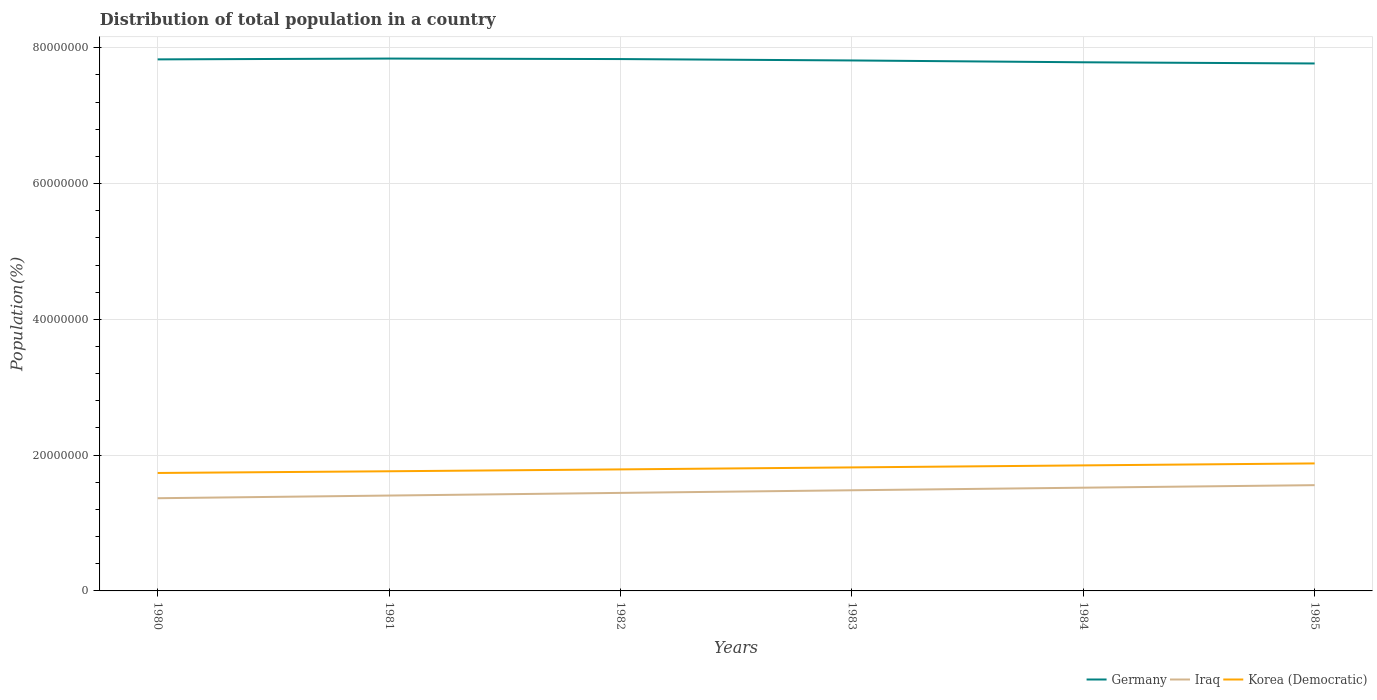How many different coloured lines are there?
Your answer should be compact. 3. Across all years, what is the maximum population of in Iraq?
Your answer should be very brief. 1.37e+07. In which year was the population of in Korea (Democratic) maximum?
Your response must be concise. 1980. What is the total population of in Germany in the graph?
Provide a succinct answer. 2.05e+05. What is the difference between the highest and the second highest population of in Iraq?
Offer a very short reply. 1.92e+06. What is the difference between two consecutive major ticks on the Y-axis?
Make the answer very short. 2.00e+07. Are the values on the major ticks of Y-axis written in scientific E-notation?
Give a very brief answer. No. Does the graph contain grids?
Make the answer very short. Yes. How are the legend labels stacked?
Make the answer very short. Horizontal. What is the title of the graph?
Keep it short and to the point. Distribution of total population in a country. What is the label or title of the X-axis?
Give a very brief answer. Years. What is the label or title of the Y-axis?
Your response must be concise. Population(%). What is the Population(%) of Germany in 1980?
Your answer should be very brief. 7.83e+07. What is the Population(%) in Iraq in 1980?
Give a very brief answer. 1.37e+07. What is the Population(%) of Korea (Democratic) in 1980?
Keep it short and to the point. 1.74e+07. What is the Population(%) in Germany in 1981?
Your answer should be very brief. 7.84e+07. What is the Population(%) in Iraq in 1981?
Your answer should be very brief. 1.40e+07. What is the Population(%) of Korea (Democratic) in 1981?
Offer a terse response. 1.76e+07. What is the Population(%) in Germany in 1982?
Your response must be concise. 7.83e+07. What is the Population(%) of Iraq in 1982?
Your response must be concise. 1.44e+07. What is the Population(%) in Korea (Democratic) in 1982?
Offer a terse response. 1.79e+07. What is the Population(%) in Germany in 1983?
Your response must be concise. 7.81e+07. What is the Population(%) of Iraq in 1983?
Your answer should be very brief. 1.48e+07. What is the Population(%) of Korea (Democratic) in 1983?
Offer a very short reply. 1.82e+07. What is the Population(%) of Germany in 1984?
Offer a very short reply. 7.79e+07. What is the Population(%) in Iraq in 1984?
Keep it short and to the point. 1.52e+07. What is the Population(%) in Korea (Democratic) in 1984?
Give a very brief answer. 1.85e+07. What is the Population(%) of Germany in 1985?
Keep it short and to the point. 7.77e+07. What is the Population(%) of Iraq in 1985?
Your answer should be compact. 1.56e+07. What is the Population(%) in Korea (Democratic) in 1985?
Offer a terse response. 1.88e+07. Across all years, what is the maximum Population(%) in Germany?
Ensure brevity in your answer.  7.84e+07. Across all years, what is the maximum Population(%) in Iraq?
Ensure brevity in your answer.  1.56e+07. Across all years, what is the maximum Population(%) in Korea (Democratic)?
Your answer should be compact. 1.88e+07. Across all years, what is the minimum Population(%) of Germany?
Provide a succinct answer. 7.77e+07. Across all years, what is the minimum Population(%) of Iraq?
Give a very brief answer. 1.37e+07. Across all years, what is the minimum Population(%) in Korea (Democratic)?
Make the answer very short. 1.74e+07. What is the total Population(%) in Germany in the graph?
Provide a succinct answer. 4.69e+08. What is the total Population(%) in Iraq in the graph?
Ensure brevity in your answer.  8.77e+07. What is the total Population(%) of Korea (Democratic) in the graph?
Ensure brevity in your answer.  1.08e+08. What is the difference between the Population(%) in Germany in 1980 and that in 1981?
Your answer should be compact. -1.19e+05. What is the difference between the Population(%) in Iraq in 1980 and that in 1981?
Your response must be concise. -3.93e+05. What is the difference between the Population(%) in Korea (Democratic) in 1980 and that in 1981?
Your response must be concise. -2.51e+05. What is the difference between the Population(%) of Germany in 1980 and that in 1982?
Your answer should be compact. -4.48e+04. What is the difference between the Population(%) in Iraq in 1980 and that in 1982?
Make the answer very short. -7.84e+05. What is the difference between the Population(%) in Korea (Democratic) in 1980 and that in 1982?
Provide a succinct answer. -5.27e+05. What is the difference between the Population(%) in Germany in 1980 and that in 1983?
Your response must be concise. 1.60e+05. What is the difference between the Population(%) of Iraq in 1980 and that in 1983?
Your answer should be compact. -1.17e+06. What is the difference between the Population(%) in Korea (Democratic) in 1980 and that in 1983?
Ensure brevity in your answer.  -8.20e+05. What is the difference between the Population(%) of Germany in 1980 and that in 1984?
Provide a succinct answer. 4.30e+05. What is the difference between the Population(%) of Iraq in 1980 and that in 1984?
Give a very brief answer. -1.55e+06. What is the difference between the Population(%) of Korea (Democratic) in 1980 and that in 1984?
Offer a terse response. -1.12e+06. What is the difference between the Population(%) in Germany in 1980 and that in 1985?
Your response must be concise. 6.04e+05. What is the difference between the Population(%) of Iraq in 1980 and that in 1985?
Offer a very short reply. -1.92e+06. What is the difference between the Population(%) of Korea (Democratic) in 1980 and that in 1985?
Keep it short and to the point. -1.41e+06. What is the difference between the Population(%) in Germany in 1981 and that in 1982?
Ensure brevity in your answer.  7.45e+04. What is the difference between the Population(%) of Iraq in 1981 and that in 1982?
Offer a terse response. -3.91e+05. What is the difference between the Population(%) of Korea (Democratic) in 1981 and that in 1982?
Offer a terse response. -2.76e+05. What is the difference between the Population(%) of Germany in 1981 and that in 1983?
Provide a short and direct response. 2.80e+05. What is the difference between the Population(%) in Iraq in 1981 and that in 1983?
Your response must be concise. -7.79e+05. What is the difference between the Population(%) of Korea (Democratic) in 1981 and that in 1983?
Make the answer very short. -5.69e+05. What is the difference between the Population(%) of Germany in 1981 and that in 1984?
Offer a very short reply. 5.49e+05. What is the difference between the Population(%) in Iraq in 1981 and that in 1984?
Offer a very short reply. -1.16e+06. What is the difference between the Population(%) in Korea (Democratic) in 1981 and that in 1984?
Provide a short and direct response. -8.65e+05. What is the difference between the Population(%) in Germany in 1981 and that in 1985?
Keep it short and to the point. 7.23e+05. What is the difference between the Population(%) in Iraq in 1981 and that in 1985?
Give a very brief answer. -1.53e+06. What is the difference between the Population(%) in Korea (Democratic) in 1981 and that in 1985?
Offer a very short reply. -1.15e+06. What is the difference between the Population(%) in Germany in 1982 and that in 1983?
Your response must be concise. 2.05e+05. What is the difference between the Population(%) of Iraq in 1982 and that in 1983?
Give a very brief answer. -3.87e+05. What is the difference between the Population(%) in Korea (Democratic) in 1982 and that in 1983?
Keep it short and to the point. -2.93e+05. What is the difference between the Population(%) of Germany in 1982 and that in 1984?
Keep it short and to the point. 4.75e+05. What is the difference between the Population(%) of Iraq in 1982 and that in 1984?
Your response must be concise. -7.67e+05. What is the difference between the Population(%) in Korea (Democratic) in 1982 and that in 1984?
Give a very brief answer. -5.89e+05. What is the difference between the Population(%) of Germany in 1982 and that in 1985?
Ensure brevity in your answer.  6.48e+05. What is the difference between the Population(%) of Iraq in 1982 and that in 1985?
Your response must be concise. -1.14e+06. What is the difference between the Population(%) of Korea (Democratic) in 1982 and that in 1985?
Provide a short and direct response. -8.79e+05. What is the difference between the Population(%) in Germany in 1983 and that in 1984?
Your answer should be compact. 2.70e+05. What is the difference between the Population(%) of Iraq in 1983 and that in 1984?
Ensure brevity in your answer.  -3.80e+05. What is the difference between the Population(%) in Korea (Democratic) in 1983 and that in 1984?
Your answer should be compact. -2.96e+05. What is the difference between the Population(%) in Germany in 1983 and that in 1985?
Keep it short and to the point. 4.43e+05. What is the difference between the Population(%) of Iraq in 1983 and that in 1985?
Offer a very short reply. -7.52e+05. What is the difference between the Population(%) in Korea (Democratic) in 1983 and that in 1985?
Give a very brief answer. -5.86e+05. What is the difference between the Population(%) in Germany in 1984 and that in 1985?
Offer a very short reply. 1.74e+05. What is the difference between the Population(%) in Iraq in 1984 and that in 1985?
Your answer should be compact. -3.72e+05. What is the difference between the Population(%) of Korea (Democratic) in 1984 and that in 1985?
Offer a very short reply. -2.90e+05. What is the difference between the Population(%) of Germany in 1980 and the Population(%) of Iraq in 1981?
Make the answer very short. 6.42e+07. What is the difference between the Population(%) in Germany in 1980 and the Population(%) in Korea (Democratic) in 1981?
Provide a succinct answer. 6.07e+07. What is the difference between the Population(%) of Iraq in 1980 and the Population(%) of Korea (Democratic) in 1981?
Provide a short and direct response. -3.97e+06. What is the difference between the Population(%) of Germany in 1980 and the Population(%) of Iraq in 1982?
Your answer should be very brief. 6.39e+07. What is the difference between the Population(%) of Germany in 1980 and the Population(%) of Korea (Democratic) in 1982?
Offer a very short reply. 6.04e+07. What is the difference between the Population(%) in Iraq in 1980 and the Population(%) in Korea (Democratic) in 1982?
Your answer should be compact. -4.25e+06. What is the difference between the Population(%) in Germany in 1980 and the Population(%) in Iraq in 1983?
Ensure brevity in your answer.  6.35e+07. What is the difference between the Population(%) in Germany in 1980 and the Population(%) in Korea (Democratic) in 1983?
Your answer should be very brief. 6.01e+07. What is the difference between the Population(%) in Iraq in 1980 and the Population(%) in Korea (Democratic) in 1983?
Keep it short and to the point. -4.54e+06. What is the difference between the Population(%) of Germany in 1980 and the Population(%) of Iraq in 1984?
Provide a succinct answer. 6.31e+07. What is the difference between the Population(%) of Germany in 1980 and the Population(%) of Korea (Democratic) in 1984?
Your answer should be compact. 5.98e+07. What is the difference between the Population(%) of Iraq in 1980 and the Population(%) of Korea (Democratic) in 1984?
Give a very brief answer. -4.83e+06. What is the difference between the Population(%) of Germany in 1980 and the Population(%) of Iraq in 1985?
Provide a short and direct response. 6.27e+07. What is the difference between the Population(%) of Germany in 1980 and the Population(%) of Korea (Democratic) in 1985?
Keep it short and to the point. 5.95e+07. What is the difference between the Population(%) of Iraq in 1980 and the Population(%) of Korea (Democratic) in 1985?
Give a very brief answer. -5.12e+06. What is the difference between the Population(%) of Germany in 1981 and the Population(%) of Iraq in 1982?
Provide a short and direct response. 6.40e+07. What is the difference between the Population(%) of Germany in 1981 and the Population(%) of Korea (Democratic) in 1982?
Your answer should be very brief. 6.05e+07. What is the difference between the Population(%) of Iraq in 1981 and the Population(%) of Korea (Democratic) in 1982?
Give a very brief answer. -3.85e+06. What is the difference between the Population(%) in Germany in 1981 and the Population(%) in Iraq in 1983?
Provide a short and direct response. 6.36e+07. What is the difference between the Population(%) of Germany in 1981 and the Population(%) of Korea (Democratic) in 1983?
Provide a succinct answer. 6.02e+07. What is the difference between the Population(%) in Iraq in 1981 and the Population(%) in Korea (Democratic) in 1983?
Offer a very short reply. -4.15e+06. What is the difference between the Population(%) in Germany in 1981 and the Population(%) in Iraq in 1984?
Keep it short and to the point. 6.32e+07. What is the difference between the Population(%) of Germany in 1981 and the Population(%) of Korea (Democratic) in 1984?
Provide a short and direct response. 5.99e+07. What is the difference between the Population(%) of Iraq in 1981 and the Population(%) of Korea (Democratic) in 1984?
Provide a succinct answer. -4.44e+06. What is the difference between the Population(%) of Germany in 1981 and the Population(%) of Iraq in 1985?
Give a very brief answer. 6.28e+07. What is the difference between the Population(%) in Germany in 1981 and the Population(%) in Korea (Democratic) in 1985?
Offer a terse response. 5.96e+07. What is the difference between the Population(%) in Iraq in 1981 and the Population(%) in Korea (Democratic) in 1985?
Offer a very short reply. -4.73e+06. What is the difference between the Population(%) of Germany in 1982 and the Population(%) of Iraq in 1983?
Provide a succinct answer. 6.35e+07. What is the difference between the Population(%) in Germany in 1982 and the Population(%) in Korea (Democratic) in 1983?
Provide a short and direct response. 6.01e+07. What is the difference between the Population(%) in Iraq in 1982 and the Population(%) in Korea (Democratic) in 1983?
Ensure brevity in your answer.  -3.75e+06. What is the difference between the Population(%) of Germany in 1982 and the Population(%) of Iraq in 1984?
Make the answer very short. 6.31e+07. What is the difference between the Population(%) in Germany in 1982 and the Population(%) in Korea (Democratic) in 1984?
Ensure brevity in your answer.  5.98e+07. What is the difference between the Population(%) in Iraq in 1982 and the Population(%) in Korea (Democratic) in 1984?
Keep it short and to the point. -4.05e+06. What is the difference between the Population(%) of Germany in 1982 and the Population(%) of Iraq in 1985?
Offer a very short reply. 6.28e+07. What is the difference between the Population(%) in Germany in 1982 and the Population(%) in Korea (Democratic) in 1985?
Your answer should be compact. 5.96e+07. What is the difference between the Population(%) in Iraq in 1982 and the Population(%) in Korea (Democratic) in 1985?
Your answer should be compact. -4.34e+06. What is the difference between the Population(%) of Germany in 1983 and the Population(%) of Iraq in 1984?
Provide a succinct answer. 6.29e+07. What is the difference between the Population(%) of Germany in 1983 and the Population(%) of Korea (Democratic) in 1984?
Ensure brevity in your answer.  5.96e+07. What is the difference between the Population(%) of Iraq in 1983 and the Population(%) of Korea (Democratic) in 1984?
Offer a terse response. -3.66e+06. What is the difference between the Population(%) of Germany in 1983 and the Population(%) of Iraq in 1985?
Provide a short and direct response. 6.26e+07. What is the difference between the Population(%) in Germany in 1983 and the Population(%) in Korea (Democratic) in 1985?
Provide a succinct answer. 5.94e+07. What is the difference between the Population(%) in Iraq in 1983 and the Population(%) in Korea (Democratic) in 1985?
Make the answer very short. -3.95e+06. What is the difference between the Population(%) in Germany in 1984 and the Population(%) in Iraq in 1985?
Provide a succinct answer. 6.23e+07. What is the difference between the Population(%) in Germany in 1984 and the Population(%) in Korea (Democratic) in 1985?
Provide a short and direct response. 5.91e+07. What is the difference between the Population(%) of Iraq in 1984 and the Population(%) of Korea (Democratic) in 1985?
Offer a terse response. -3.57e+06. What is the average Population(%) in Germany per year?
Ensure brevity in your answer.  7.81e+07. What is the average Population(%) in Iraq per year?
Ensure brevity in your answer.  1.46e+07. What is the average Population(%) of Korea (Democratic) per year?
Offer a very short reply. 1.81e+07. In the year 1980, what is the difference between the Population(%) of Germany and Population(%) of Iraq?
Offer a terse response. 6.46e+07. In the year 1980, what is the difference between the Population(%) in Germany and Population(%) in Korea (Democratic)?
Provide a short and direct response. 6.09e+07. In the year 1980, what is the difference between the Population(%) of Iraq and Population(%) of Korea (Democratic)?
Keep it short and to the point. -3.72e+06. In the year 1981, what is the difference between the Population(%) in Germany and Population(%) in Iraq?
Your response must be concise. 6.44e+07. In the year 1981, what is the difference between the Population(%) of Germany and Population(%) of Korea (Democratic)?
Give a very brief answer. 6.08e+07. In the year 1981, what is the difference between the Population(%) in Iraq and Population(%) in Korea (Democratic)?
Your response must be concise. -3.58e+06. In the year 1982, what is the difference between the Population(%) of Germany and Population(%) of Iraq?
Your answer should be compact. 6.39e+07. In the year 1982, what is the difference between the Population(%) in Germany and Population(%) in Korea (Democratic)?
Give a very brief answer. 6.04e+07. In the year 1982, what is the difference between the Population(%) of Iraq and Population(%) of Korea (Democratic)?
Your answer should be very brief. -3.46e+06. In the year 1983, what is the difference between the Population(%) in Germany and Population(%) in Iraq?
Make the answer very short. 6.33e+07. In the year 1983, what is the difference between the Population(%) of Germany and Population(%) of Korea (Democratic)?
Make the answer very short. 5.99e+07. In the year 1983, what is the difference between the Population(%) of Iraq and Population(%) of Korea (Democratic)?
Provide a short and direct response. -3.37e+06. In the year 1984, what is the difference between the Population(%) of Germany and Population(%) of Iraq?
Give a very brief answer. 6.27e+07. In the year 1984, what is the difference between the Population(%) of Germany and Population(%) of Korea (Democratic)?
Give a very brief answer. 5.94e+07. In the year 1984, what is the difference between the Population(%) in Iraq and Population(%) in Korea (Democratic)?
Provide a short and direct response. -3.28e+06. In the year 1985, what is the difference between the Population(%) in Germany and Population(%) in Iraq?
Give a very brief answer. 6.21e+07. In the year 1985, what is the difference between the Population(%) in Germany and Population(%) in Korea (Democratic)?
Offer a very short reply. 5.89e+07. In the year 1985, what is the difference between the Population(%) of Iraq and Population(%) of Korea (Democratic)?
Offer a terse response. -3.20e+06. What is the ratio of the Population(%) of Germany in 1980 to that in 1981?
Ensure brevity in your answer.  1. What is the ratio of the Population(%) of Korea (Democratic) in 1980 to that in 1981?
Your answer should be very brief. 0.99. What is the ratio of the Population(%) of Germany in 1980 to that in 1982?
Provide a succinct answer. 1. What is the ratio of the Population(%) in Iraq in 1980 to that in 1982?
Offer a very short reply. 0.95. What is the ratio of the Population(%) of Korea (Democratic) in 1980 to that in 1982?
Provide a succinct answer. 0.97. What is the ratio of the Population(%) in Iraq in 1980 to that in 1983?
Keep it short and to the point. 0.92. What is the ratio of the Population(%) of Korea (Democratic) in 1980 to that in 1983?
Your response must be concise. 0.95. What is the ratio of the Population(%) in Iraq in 1980 to that in 1984?
Ensure brevity in your answer.  0.9. What is the ratio of the Population(%) of Korea (Democratic) in 1980 to that in 1984?
Offer a very short reply. 0.94. What is the ratio of the Population(%) of Iraq in 1980 to that in 1985?
Ensure brevity in your answer.  0.88. What is the ratio of the Population(%) in Korea (Democratic) in 1980 to that in 1985?
Your answer should be compact. 0.93. What is the ratio of the Population(%) in Iraq in 1981 to that in 1982?
Make the answer very short. 0.97. What is the ratio of the Population(%) of Korea (Democratic) in 1981 to that in 1982?
Give a very brief answer. 0.98. What is the ratio of the Population(%) of Germany in 1981 to that in 1983?
Provide a short and direct response. 1. What is the ratio of the Population(%) of Iraq in 1981 to that in 1983?
Your answer should be very brief. 0.95. What is the ratio of the Population(%) of Korea (Democratic) in 1981 to that in 1983?
Make the answer very short. 0.97. What is the ratio of the Population(%) of Germany in 1981 to that in 1984?
Give a very brief answer. 1.01. What is the ratio of the Population(%) in Iraq in 1981 to that in 1984?
Provide a succinct answer. 0.92. What is the ratio of the Population(%) of Korea (Democratic) in 1981 to that in 1984?
Provide a short and direct response. 0.95. What is the ratio of the Population(%) in Germany in 1981 to that in 1985?
Your answer should be compact. 1.01. What is the ratio of the Population(%) in Iraq in 1981 to that in 1985?
Give a very brief answer. 0.9. What is the ratio of the Population(%) of Korea (Democratic) in 1981 to that in 1985?
Give a very brief answer. 0.94. What is the ratio of the Population(%) in Germany in 1982 to that in 1983?
Make the answer very short. 1. What is the ratio of the Population(%) in Iraq in 1982 to that in 1983?
Provide a succinct answer. 0.97. What is the ratio of the Population(%) of Korea (Democratic) in 1982 to that in 1983?
Your answer should be very brief. 0.98. What is the ratio of the Population(%) in Germany in 1982 to that in 1984?
Your answer should be very brief. 1.01. What is the ratio of the Population(%) in Iraq in 1982 to that in 1984?
Make the answer very short. 0.95. What is the ratio of the Population(%) in Korea (Democratic) in 1982 to that in 1984?
Your response must be concise. 0.97. What is the ratio of the Population(%) in Germany in 1982 to that in 1985?
Make the answer very short. 1.01. What is the ratio of the Population(%) of Iraq in 1982 to that in 1985?
Keep it short and to the point. 0.93. What is the ratio of the Population(%) of Korea (Democratic) in 1982 to that in 1985?
Make the answer very short. 0.95. What is the ratio of the Population(%) of Germany in 1983 to that in 1984?
Provide a short and direct response. 1. What is the ratio of the Population(%) of Iraq in 1983 to that in 1984?
Keep it short and to the point. 0.97. What is the ratio of the Population(%) of Korea (Democratic) in 1983 to that in 1984?
Keep it short and to the point. 0.98. What is the ratio of the Population(%) in Germany in 1983 to that in 1985?
Your answer should be compact. 1.01. What is the ratio of the Population(%) in Iraq in 1983 to that in 1985?
Provide a succinct answer. 0.95. What is the ratio of the Population(%) in Korea (Democratic) in 1983 to that in 1985?
Your answer should be very brief. 0.97. What is the ratio of the Population(%) of Germany in 1984 to that in 1985?
Your answer should be compact. 1. What is the ratio of the Population(%) in Iraq in 1984 to that in 1985?
Keep it short and to the point. 0.98. What is the ratio of the Population(%) in Korea (Democratic) in 1984 to that in 1985?
Provide a short and direct response. 0.98. What is the difference between the highest and the second highest Population(%) of Germany?
Ensure brevity in your answer.  7.45e+04. What is the difference between the highest and the second highest Population(%) of Iraq?
Give a very brief answer. 3.72e+05. What is the difference between the highest and the second highest Population(%) in Korea (Democratic)?
Offer a terse response. 2.90e+05. What is the difference between the highest and the lowest Population(%) in Germany?
Offer a terse response. 7.23e+05. What is the difference between the highest and the lowest Population(%) in Iraq?
Provide a short and direct response. 1.92e+06. What is the difference between the highest and the lowest Population(%) of Korea (Democratic)?
Your answer should be very brief. 1.41e+06. 